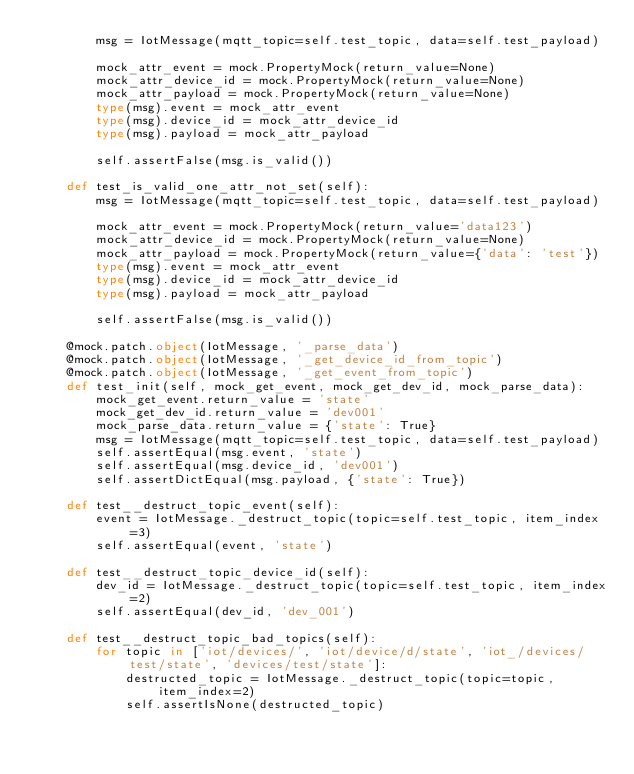Convert code to text. <code><loc_0><loc_0><loc_500><loc_500><_Python_>        msg = IotMessage(mqtt_topic=self.test_topic, data=self.test_payload)

        mock_attr_event = mock.PropertyMock(return_value=None)
        mock_attr_device_id = mock.PropertyMock(return_value=None)
        mock_attr_payload = mock.PropertyMock(return_value=None)
        type(msg).event = mock_attr_event
        type(msg).device_id = mock_attr_device_id
        type(msg).payload = mock_attr_payload

        self.assertFalse(msg.is_valid())

    def test_is_valid_one_attr_not_set(self):
        msg = IotMessage(mqtt_topic=self.test_topic, data=self.test_payload)

        mock_attr_event = mock.PropertyMock(return_value='data123')
        mock_attr_device_id = mock.PropertyMock(return_value=None)
        mock_attr_payload = mock.PropertyMock(return_value={'data': 'test'})
        type(msg).event = mock_attr_event
        type(msg).device_id = mock_attr_device_id
        type(msg).payload = mock_attr_payload

        self.assertFalse(msg.is_valid())

    @mock.patch.object(IotMessage, '_parse_data')
    @mock.patch.object(IotMessage, '_get_device_id_from_topic')
    @mock.patch.object(IotMessage, '_get_event_from_topic')
    def test_init(self, mock_get_event, mock_get_dev_id, mock_parse_data):
        mock_get_event.return_value = 'state'
        mock_get_dev_id.return_value = 'dev001'
        mock_parse_data.return_value = {'state': True}
        msg = IotMessage(mqtt_topic=self.test_topic, data=self.test_payload)
        self.assertEqual(msg.event, 'state')
        self.assertEqual(msg.device_id, 'dev001')
        self.assertDictEqual(msg.payload, {'state': True})

    def test__destruct_topic_event(self):
        event = IotMessage._destruct_topic(topic=self.test_topic, item_index=3)
        self.assertEqual(event, 'state')

    def test__destruct_topic_device_id(self):
        dev_id = IotMessage._destruct_topic(topic=self.test_topic, item_index=2)
        self.assertEqual(dev_id, 'dev_001')

    def test__destruct_topic_bad_topics(self):
        for topic in ['iot/devices/', 'iot/device/d/state', 'iot_/devices/test/state', 'devices/test/state']:
            destructed_topic = IotMessage._destruct_topic(topic=topic, item_index=2)
            self.assertIsNone(destructed_topic)
</code> 